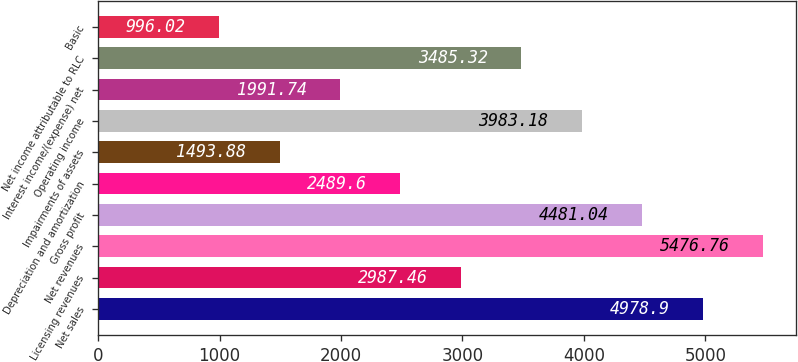Convert chart to OTSL. <chart><loc_0><loc_0><loc_500><loc_500><bar_chart><fcel>Net sales<fcel>Licensing revenues<fcel>Net revenues<fcel>Gross profit<fcel>Depreciation and amortization<fcel>Impairments of assets<fcel>Operating income<fcel>Interest income/(expense) net<fcel>Net income attributable to RLC<fcel>Basic<nl><fcel>4978.9<fcel>2987.46<fcel>5476.76<fcel>4481.04<fcel>2489.6<fcel>1493.88<fcel>3983.18<fcel>1991.74<fcel>3485.32<fcel>996.02<nl></chart> 